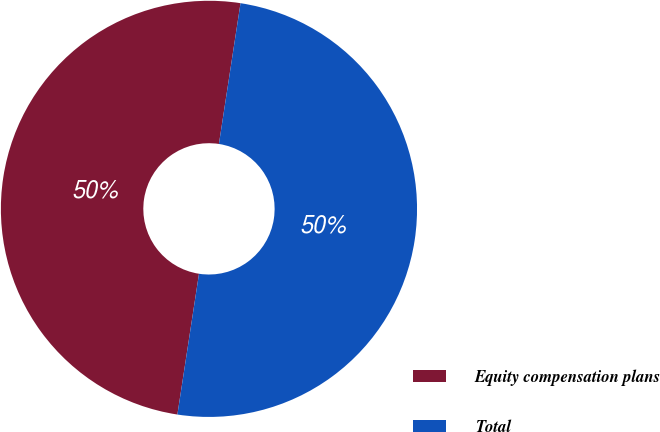Convert chart. <chart><loc_0><loc_0><loc_500><loc_500><pie_chart><fcel>Equity compensation plans<fcel>Total<nl><fcel>50.0%<fcel>50.0%<nl></chart> 